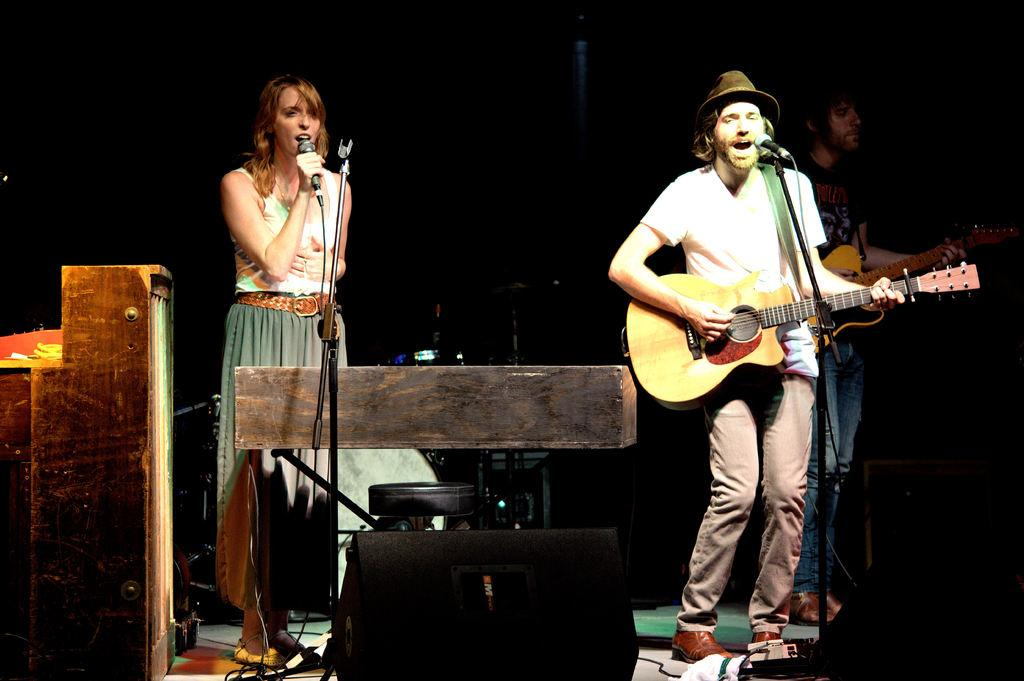What is the woman doing in the image? The woman is singing on a microphone. What is the man doing in the image? The man is playing a guitar and also singing. Are there any musical instruments present in the image? Yes, there is a guitar being played by the man. How much money is being exchanged between the woman and the man in the image? There is no indication of money being exchanged in the image; it features a woman singing on a microphone and a man playing a guitar and singing. What type of plastic object is being used by the mailbox in the image? There is no mailbox present in the image. 